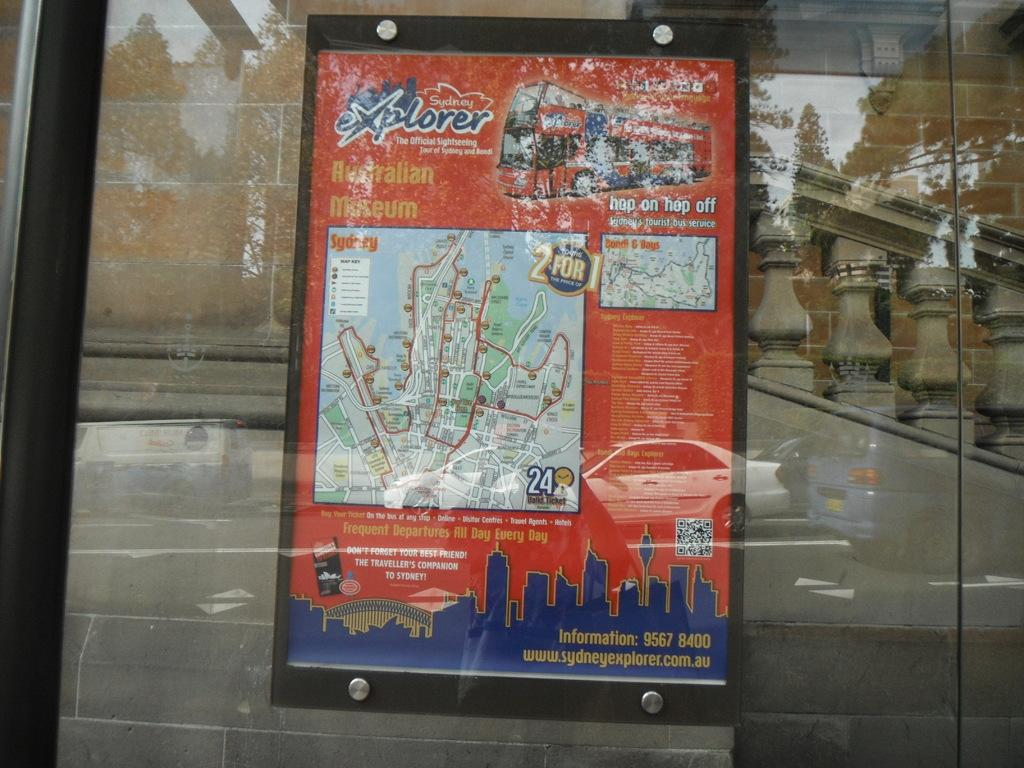<image>
Write a terse but informative summary of the picture. Sydney explorer poster for the Australian museum including a map 